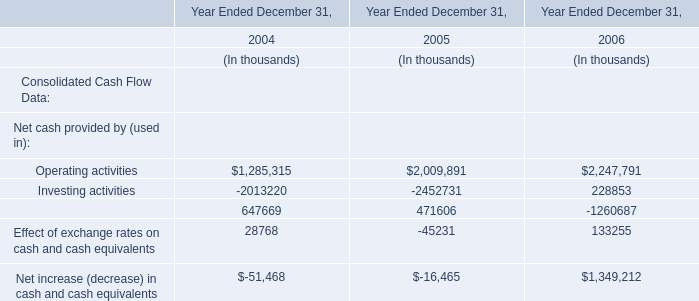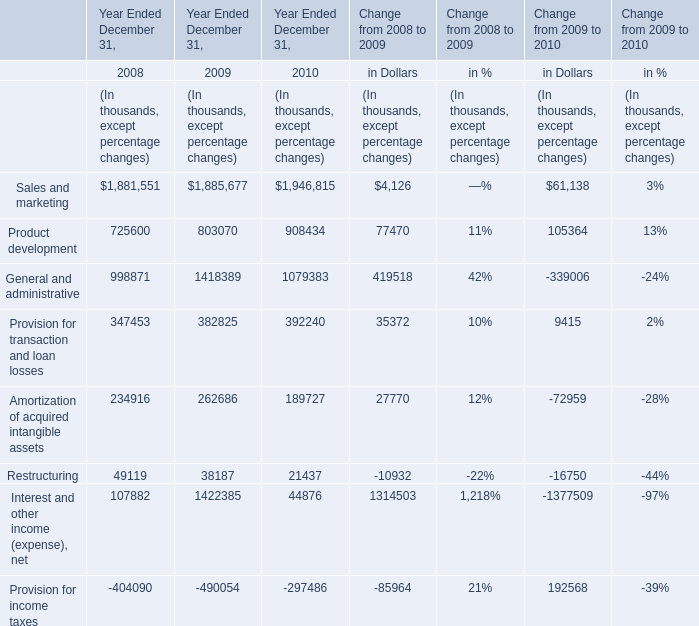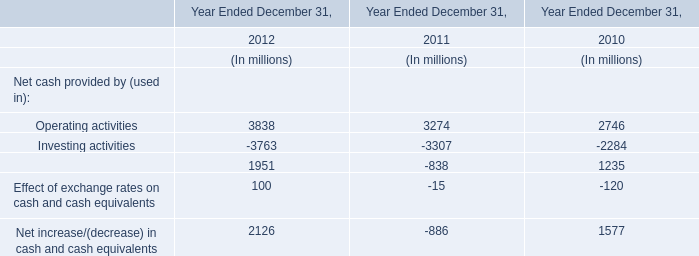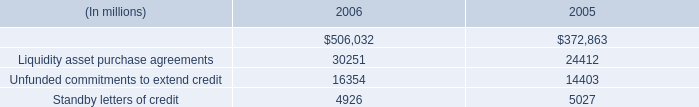What is the growing rate of Provision for transaction and loan losses in the year with the most Product development? 
Computations: ((392240 - 382825) / 382825)
Answer: 0.02459. What is the total value of Product development, General and administrative, Provision for transaction and loan losses and Amortization of acquired intangible assets in 2008? (in thousand) 
Computations: (((725600 + 998871) + 347453) + 234916)
Answer: 2306840.0. 